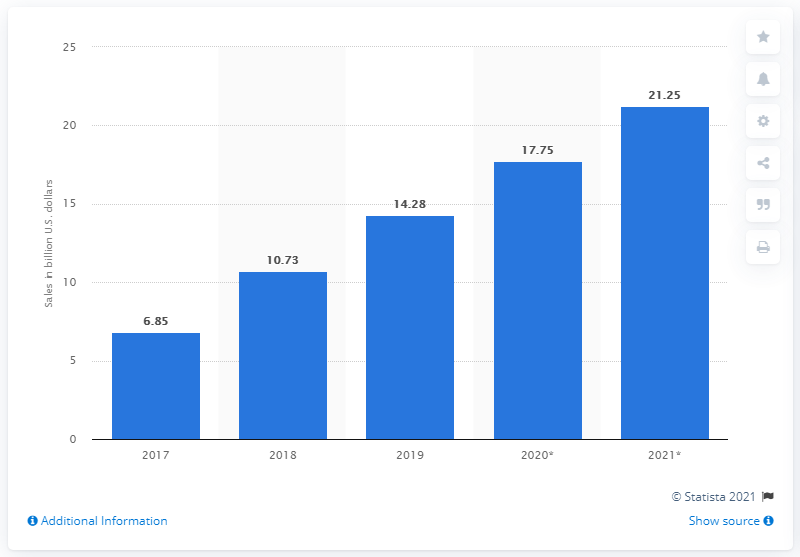Specify some key components in this picture. In 2020, direct-to-consumer e-commerce sales are projected to reach an estimated 17.75 billion dollars. In 2019, direct-to-consumer (D2C) e-commerce sales reached a significant milestone, with a total of 14.28 billion dollars in sales. In 2020, D2C e-commerce sales are projected to reach approximately $17.75 billion. 